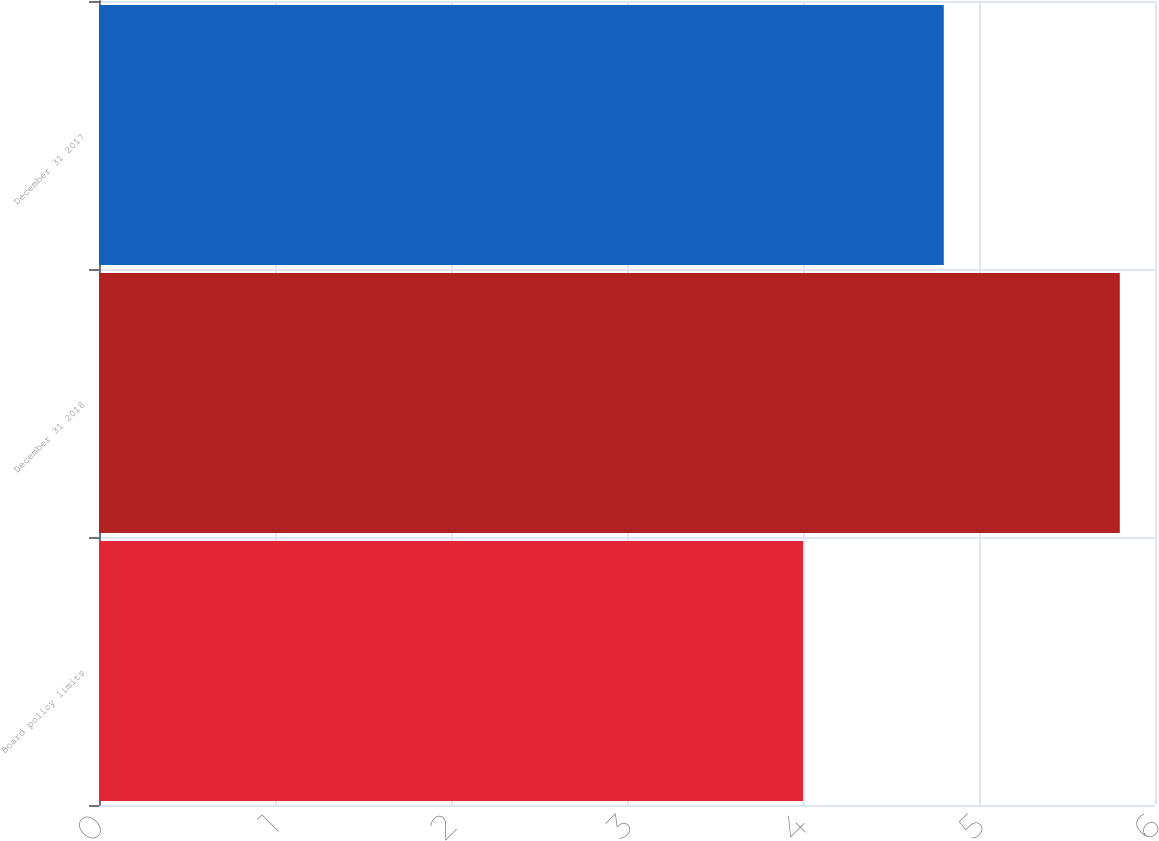Convert chart. <chart><loc_0><loc_0><loc_500><loc_500><bar_chart><fcel>Board policy limits<fcel>December 31 2018<fcel>December 31 2017<nl><fcel>4<fcel>5.8<fcel>4.8<nl></chart> 